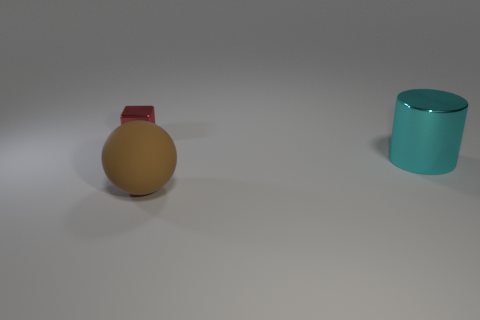Add 3 large brown matte objects. How many objects exist? 6 Subtract all blocks. How many objects are left? 2 Subtract all yellow blocks. Subtract all brown rubber objects. How many objects are left? 2 Add 2 tiny metal blocks. How many tiny metal blocks are left? 3 Add 2 metallic objects. How many metallic objects exist? 4 Subtract 1 cyan cylinders. How many objects are left? 2 